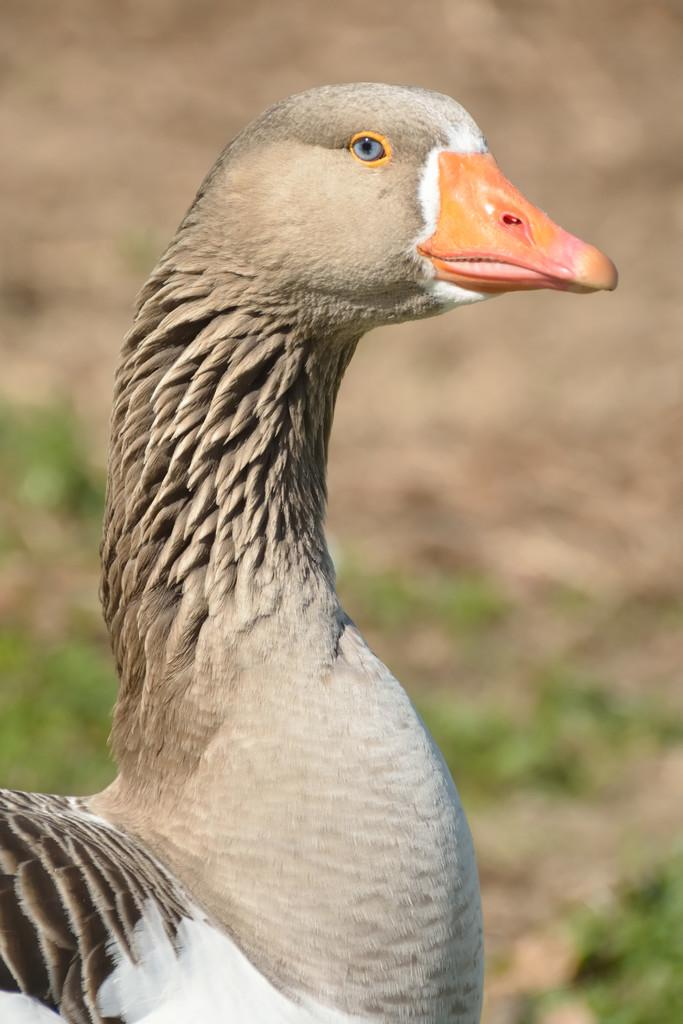What type of animal is in the image? There is a bird in the image. Can you describe the colors of the bird? The bird has white, brown, ash, and orange colors. What can be seen in the background of the image? There is ground and grass visible in the background of the image. What type of flag is being used by the bird in the image? There is no flag present in the image; it features a bird with various colors and a background of ground and grass. 